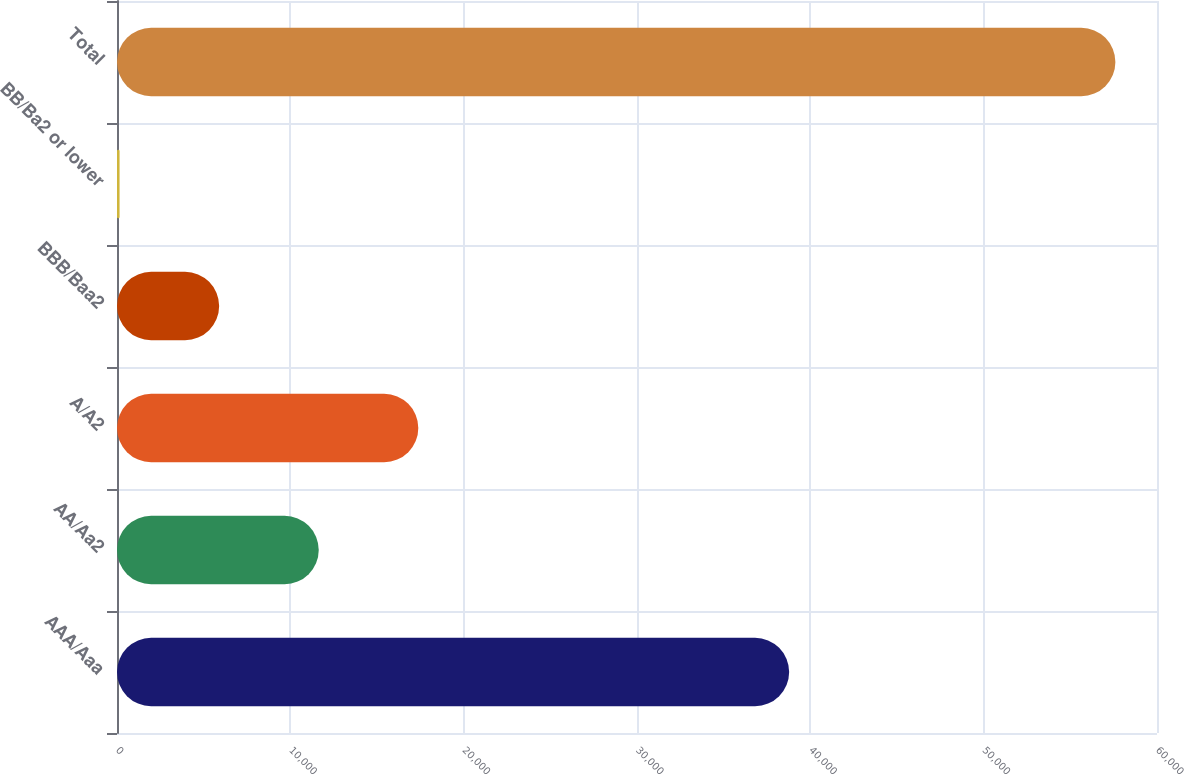Convert chart to OTSL. <chart><loc_0><loc_0><loc_500><loc_500><bar_chart><fcel>AAA/Aaa<fcel>AA/Aa2<fcel>A/A2<fcel>BBB/Baa2<fcel>BB/Ba2 or lower<fcel>Total<nl><fcel>38778<fcel>11638.4<fcel>17383.6<fcel>5893.2<fcel>148<fcel>57600<nl></chart> 